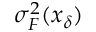Convert formula to latex. <formula><loc_0><loc_0><loc_500><loc_500>\sigma _ { F } ^ { 2 } ( x _ { \delta } )</formula> 